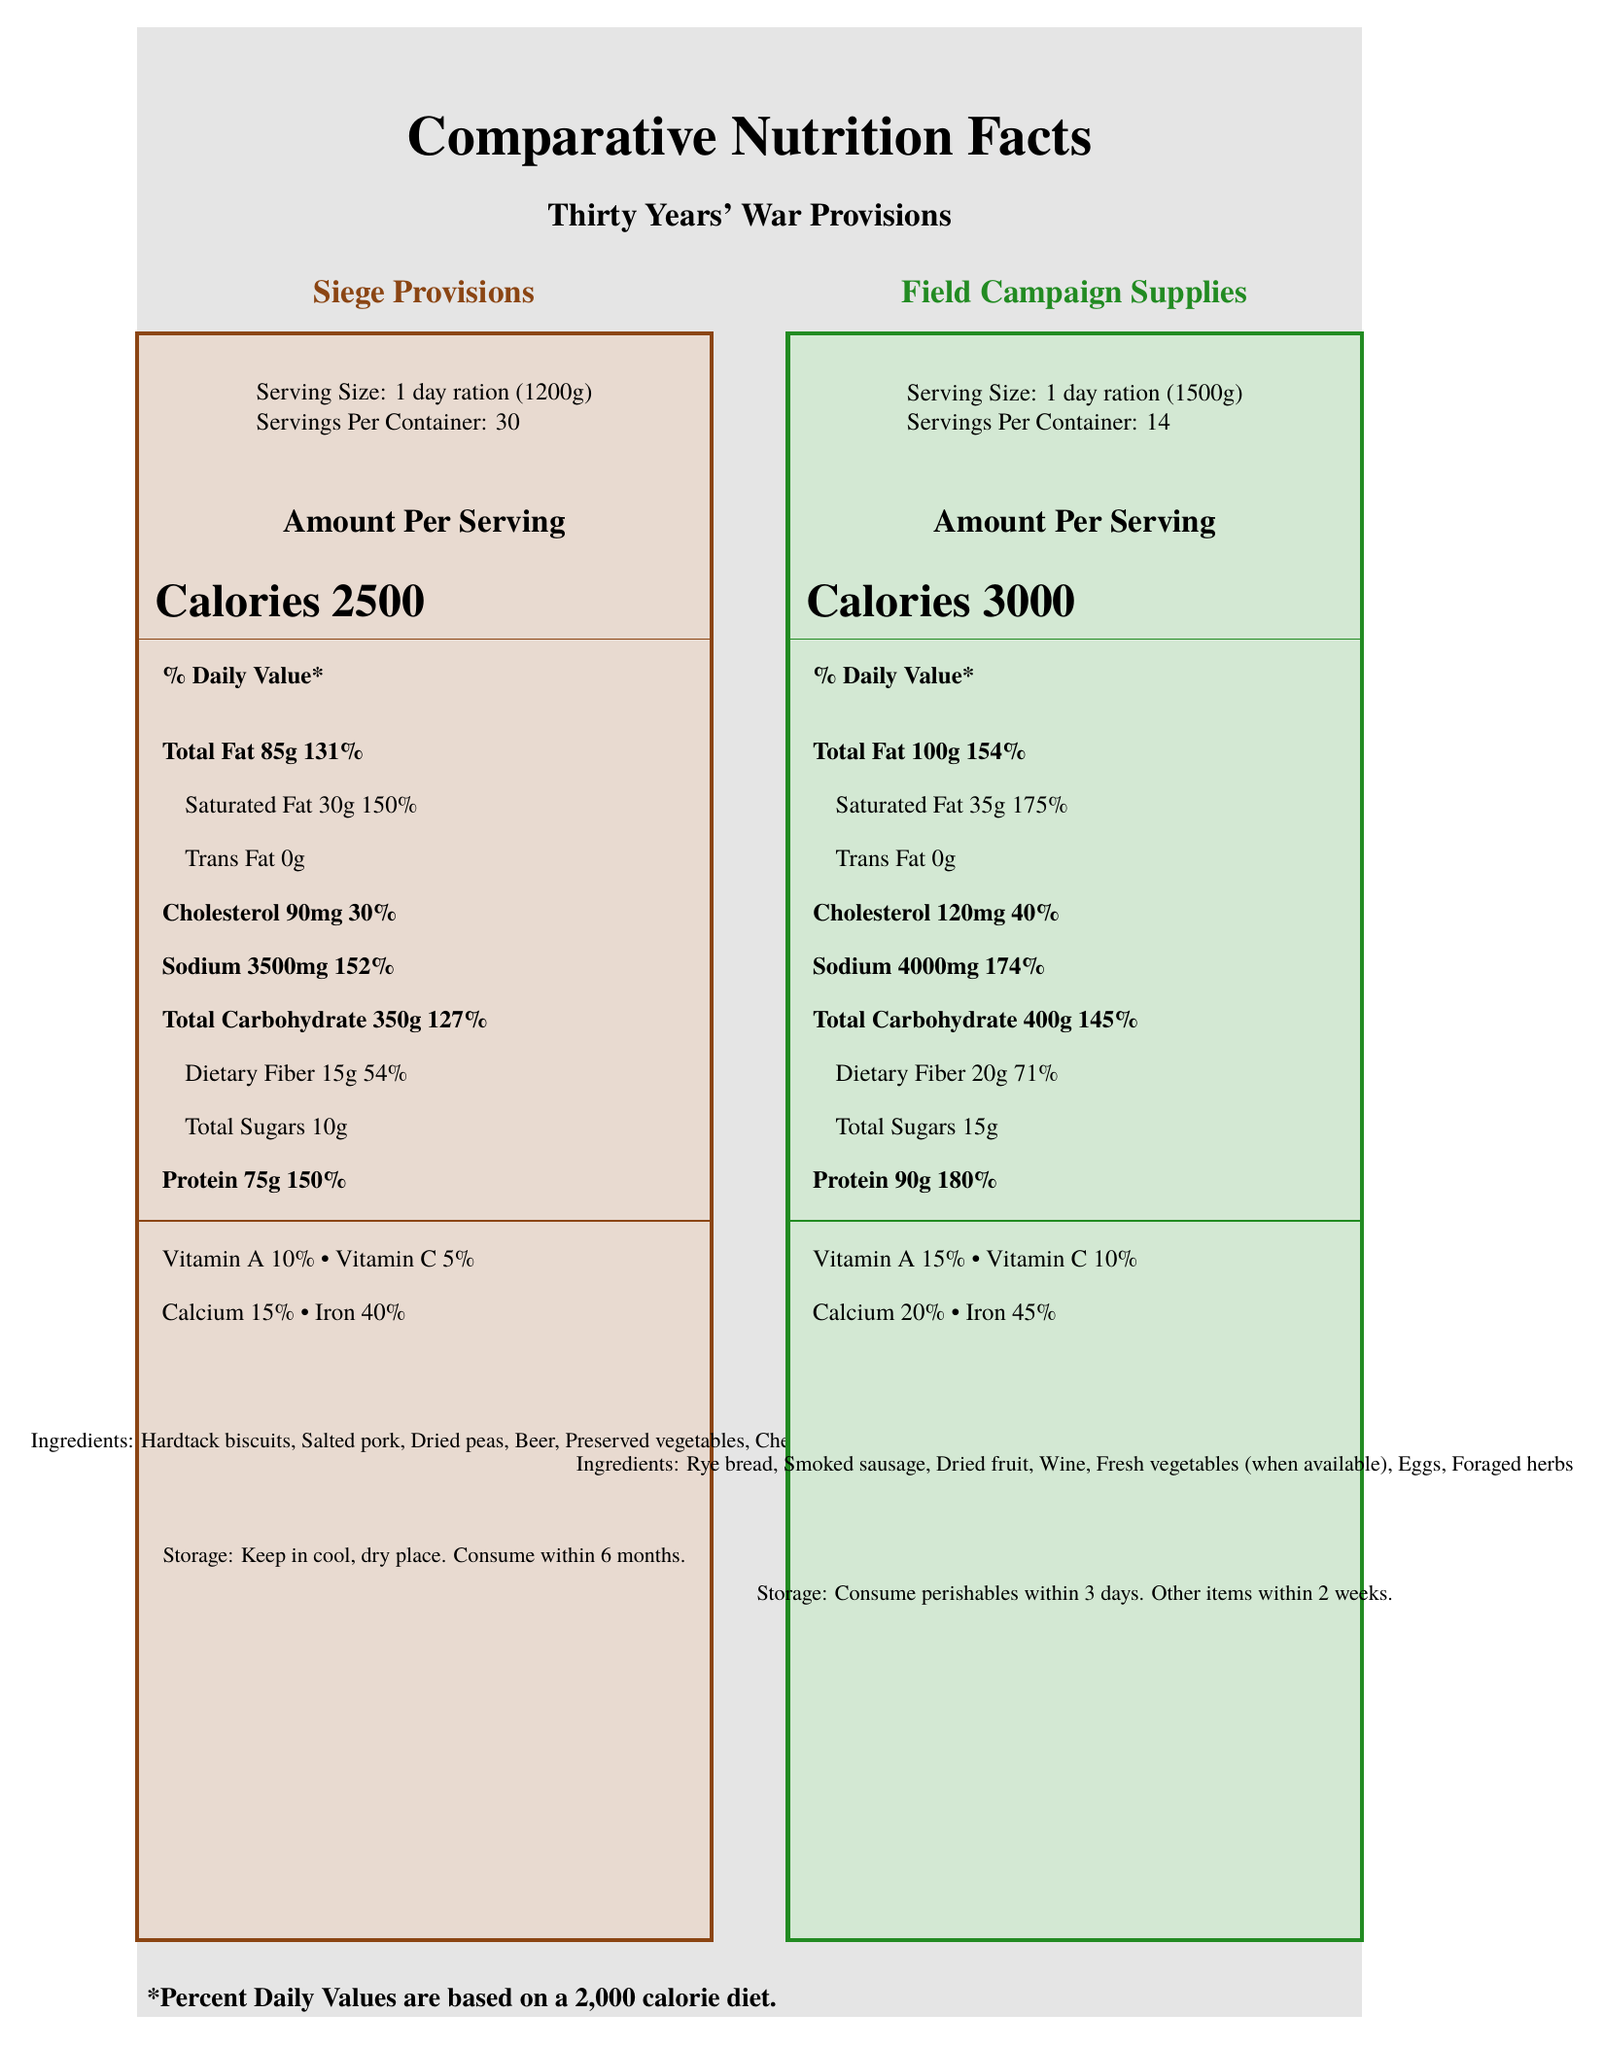what is the serving size for siege provisions? The serving size for siege provisions is explicitly stated in the document.
Answer: 1 day ration (1200g) what is the daily value percentage of iron in field campaign supplies? The document lists the daily value percentage of iron for field campaign supplies as 45%.
Answer: 45% how many calories are in a serving of field campaign supplies? The document shows that a serving of field campaign supplies contains 3000 calories.
Answer: 3000 calories what are the ingredients in siege provisions? The document lists these as the ingredients in siege provisions.
Answer: Hardtack biscuits, Salted pork, Dried peas, Beer, Preserved vegetables, Cheese how long can you store field campaign supplies' perishables? The storage instructions state to consume perishables in field campaign supplies within 3 days.
Answer: Consume perishables within 3 days which has a higher total fat content? Field campaign supplies have 100g of total fat, whereas siege provisions have 85g.
Answer: Field campaign supplies what is the percentage daily value of saturated fat in siege provisions? The percentage daily value for saturated fat in siege provisions is listed as 150%.
Answer: 150% how many servings are in one container of field campaign supplies? A. 14 B. 30 C. 21 The document states that the servings per container for field campaign supplies is 14.
Answer: A which of the following is not an ingredient in siege provisions? A. Beer B. Smoked sausage C. Cheese D. Dried peas Smoked sausage is an ingredient in field campaign supplies, not in siege provisions.
Answer: B is vitamin C content higher in field campaign supplies than in siege provisions? Field campaign supplies have 10% vitamin C, while siege provisions have only 5% vitamin C.
Answer: Yes summarize the main idea of the document. The document provides a side-by-side detailed comparison including daily values, ingredient lists, and storage instructions for both types of provisions.
Answer: The document compares the nutritional facts and ingredients of siege provisions and field campaign supplies used during the Thirty Years' War, highlighting differences in serving sizes, calorie content, and nutritional values. how do seasonal availability and logistic challenges affect military success during the Thirty Years' War? The visual document does not provide specific details on how seasonal availability and logistic challenges affect military success.
Answer: Not enough information 